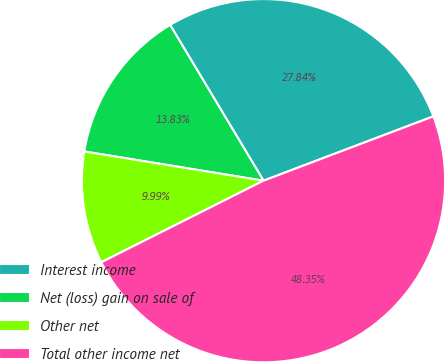<chart> <loc_0><loc_0><loc_500><loc_500><pie_chart><fcel>Interest income<fcel>Net (loss) gain on sale of<fcel>Other net<fcel>Total other income net<nl><fcel>27.84%<fcel>13.83%<fcel>9.99%<fcel>48.35%<nl></chart> 